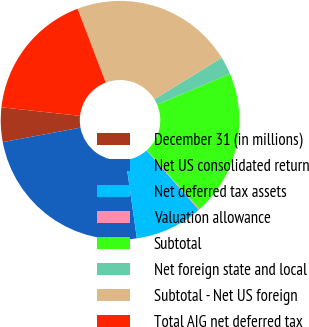Convert chart to OTSL. <chart><loc_0><loc_0><loc_500><loc_500><pie_chart><fcel>December 31 (in millions)<fcel>Net US consolidated return<fcel>Net deferred tax assets<fcel>Valuation allowance<fcel>Subtotal<fcel>Net foreign state and local<fcel>Subtotal - Net US foreign<fcel>Total AIG net deferred tax<nl><fcel>4.67%<fcel>24.31%<fcel>9.23%<fcel>0.12%<fcel>19.76%<fcel>2.4%<fcel>22.03%<fcel>17.48%<nl></chart> 